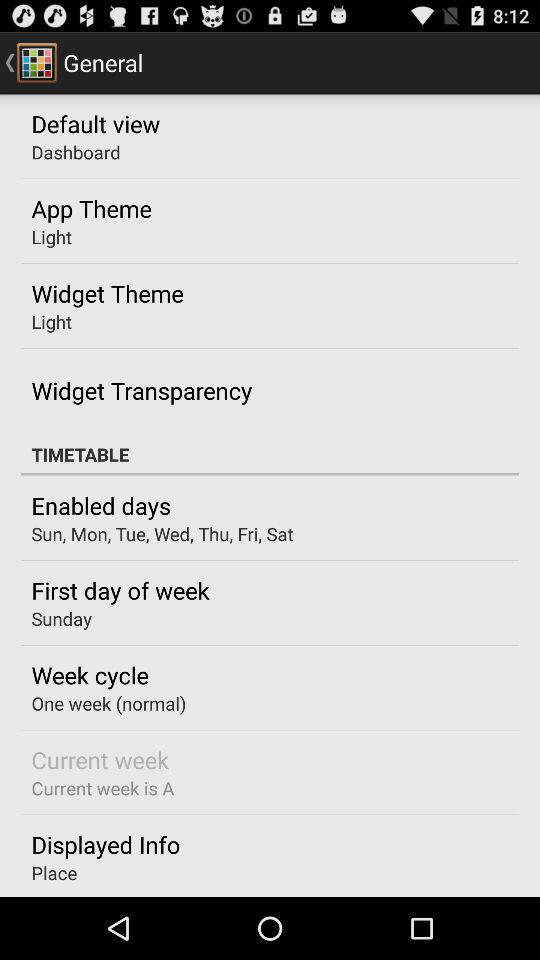What is the app theme? The app theme is light. 